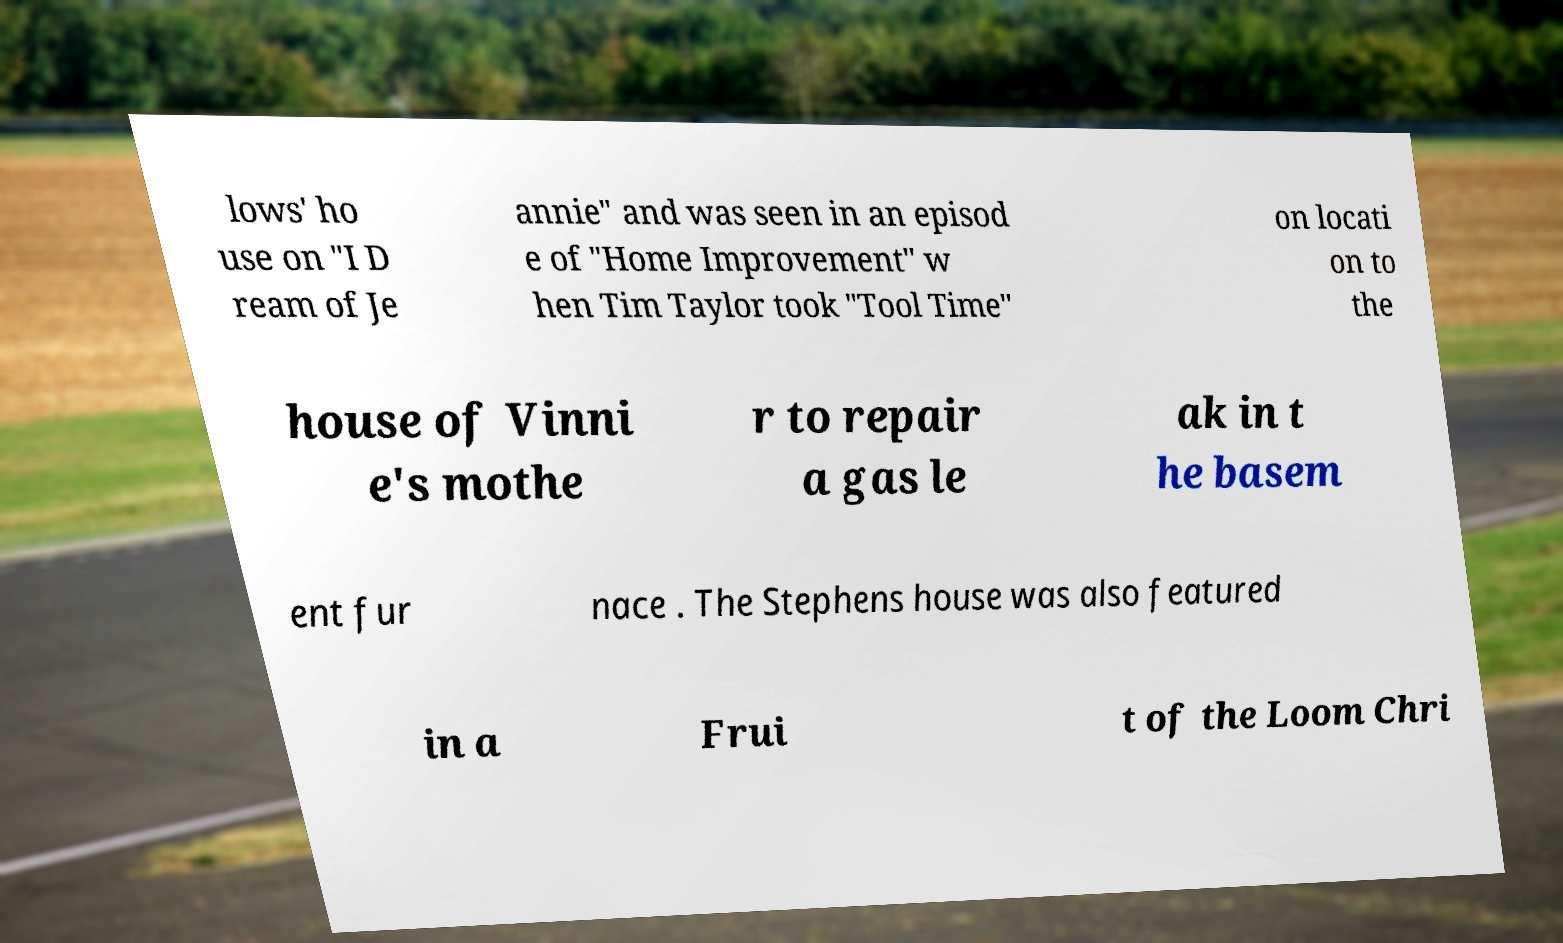I need the written content from this picture converted into text. Can you do that? lows' ho use on "I D ream of Je annie" and was seen in an episod e of "Home Improvement" w hen Tim Taylor took "Tool Time" on locati on to the house of Vinni e's mothe r to repair a gas le ak in t he basem ent fur nace . The Stephens house was also featured in a Frui t of the Loom Chri 